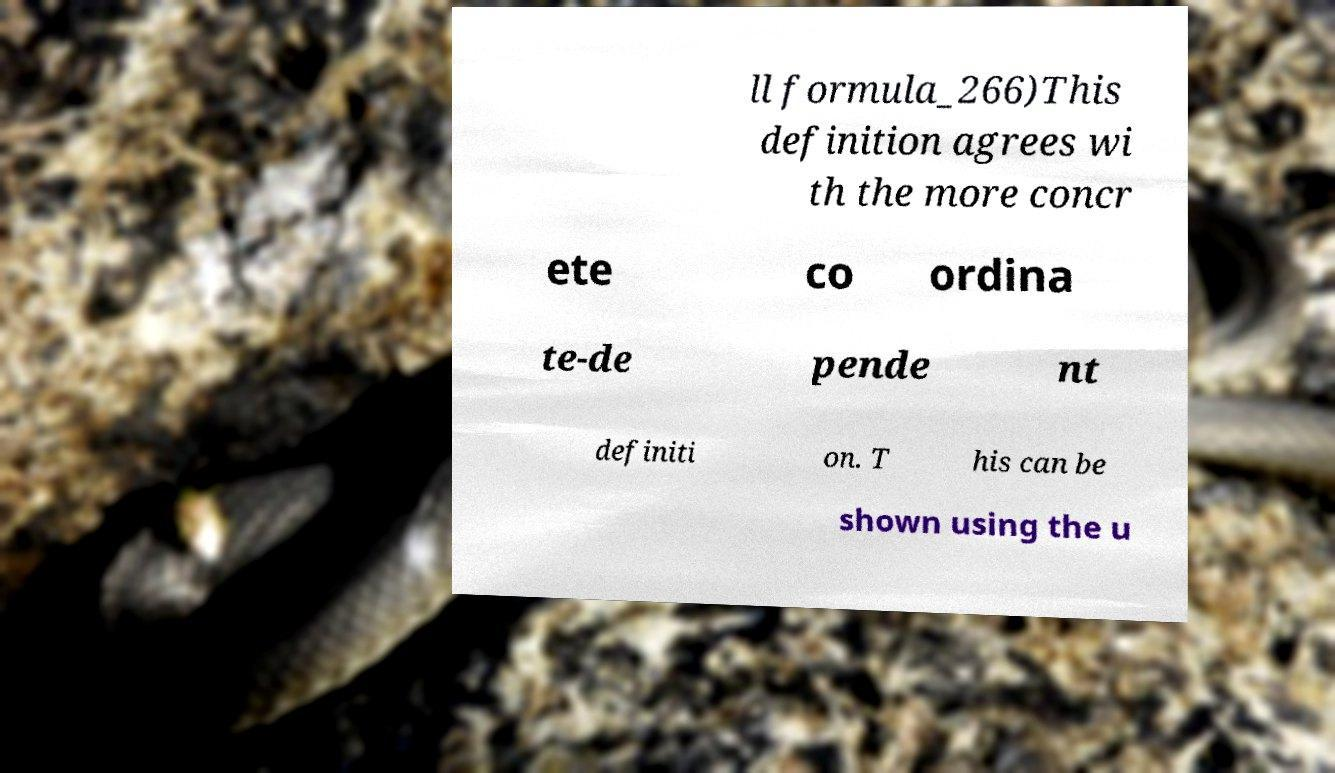Could you extract and type out the text from this image? ll formula_266)This definition agrees wi th the more concr ete co ordina te-de pende nt definiti on. T his can be shown using the u 